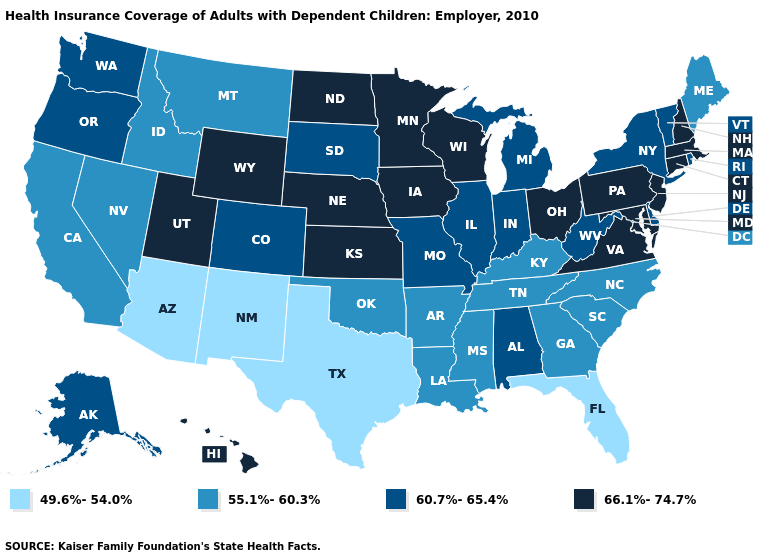Among the states that border Pennsylvania , does New York have the highest value?
Give a very brief answer. No. Does the map have missing data?
Keep it brief. No. What is the highest value in states that border Colorado?
Short answer required. 66.1%-74.7%. Does the first symbol in the legend represent the smallest category?
Be succinct. Yes. What is the lowest value in the USA?
Short answer required. 49.6%-54.0%. Does Arkansas have a lower value than Montana?
Concise answer only. No. Name the states that have a value in the range 55.1%-60.3%?
Concise answer only. Arkansas, California, Georgia, Idaho, Kentucky, Louisiana, Maine, Mississippi, Montana, Nevada, North Carolina, Oklahoma, South Carolina, Tennessee. What is the value of Nevada?
Give a very brief answer. 55.1%-60.3%. What is the lowest value in states that border Kentucky?
Keep it brief. 55.1%-60.3%. Does the first symbol in the legend represent the smallest category?
Be succinct. Yes. Name the states that have a value in the range 66.1%-74.7%?
Be succinct. Connecticut, Hawaii, Iowa, Kansas, Maryland, Massachusetts, Minnesota, Nebraska, New Hampshire, New Jersey, North Dakota, Ohio, Pennsylvania, Utah, Virginia, Wisconsin, Wyoming. What is the highest value in the USA?
Concise answer only. 66.1%-74.7%. Which states have the highest value in the USA?
Be succinct. Connecticut, Hawaii, Iowa, Kansas, Maryland, Massachusetts, Minnesota, Nebraska, New Hampshire, New Jersey, North Dakota, Ohio, Pennsylvania, Utah, Virginia, Wisconsin, Wyoming. What is the highest value in the South ?
Be succinct. 66.1%-74.7%. Does Florida have the lowest value in the USA?
Answer briefly. Yes. 